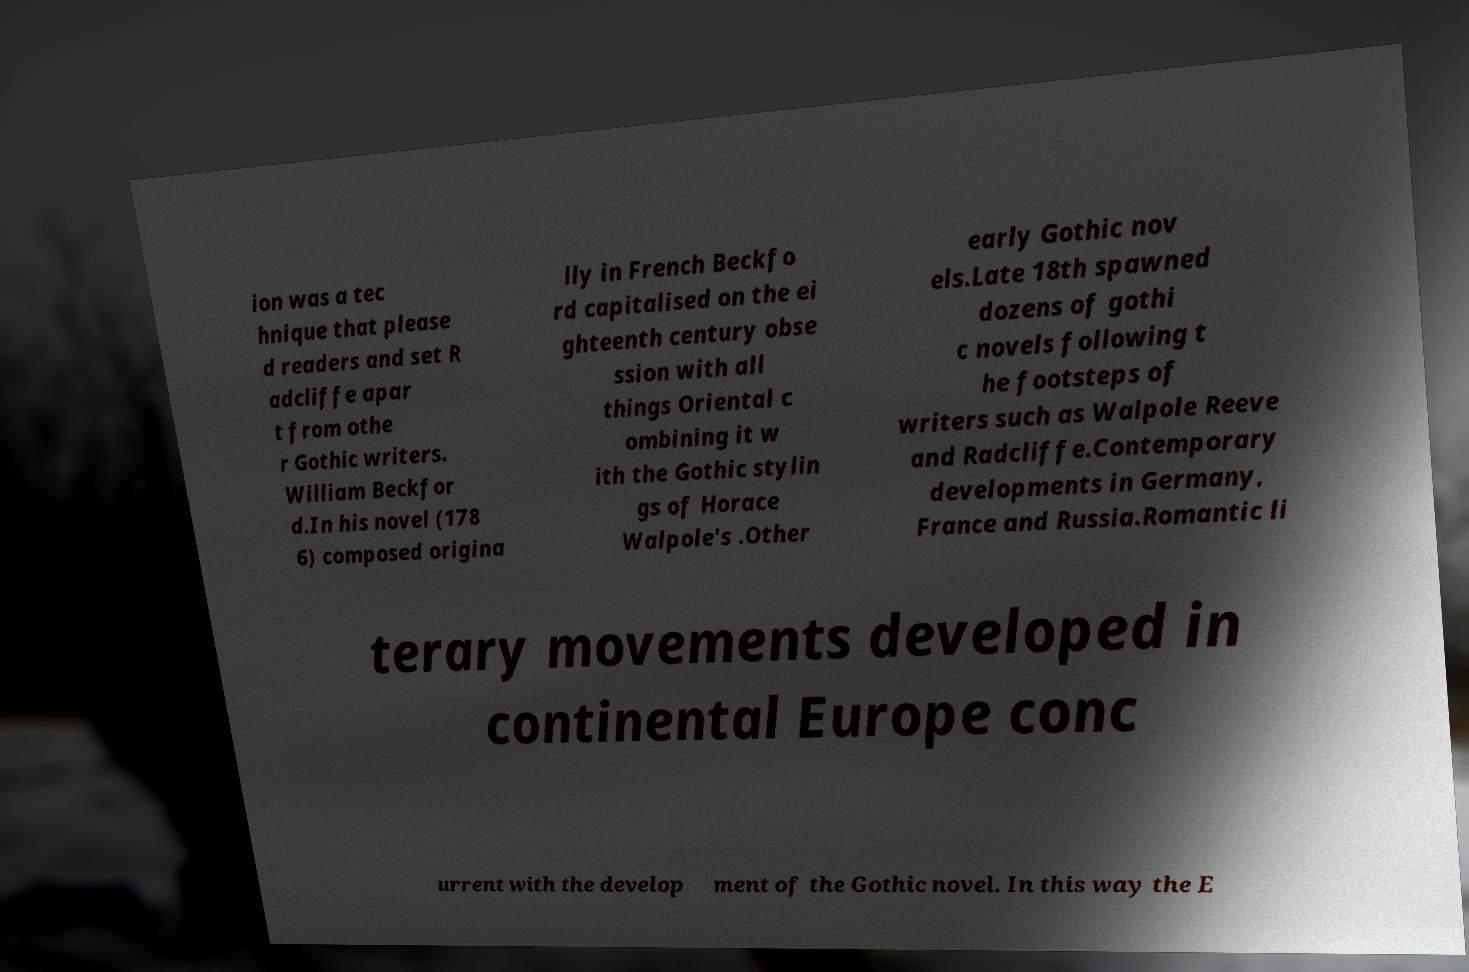There's text embedded in this image that I need extracted. Can you transcribe it verbatim? ion was a tec hnique that please d readers and set R adcliffe apar t from othe r Gothic writers. William Beckfor d.In his novel (178 6) composed origina lly in French Beckfo rd capitalised on the ei ghteenth century obse ssion with all things Oriental c ombining it w ith the Gothic stylin gs of Horace Walpole's .Other early Gothic nov els.Late 18th spawned dozens of gothi c novels following t he footsteps of writers such as Walpole Reeve and Radcliffe.Contemporary developments in Germany, France and Russia.Romantic li terary movements developed in continental Europe conc urrent with the develop ment of the Gothic novel. In this way the E 